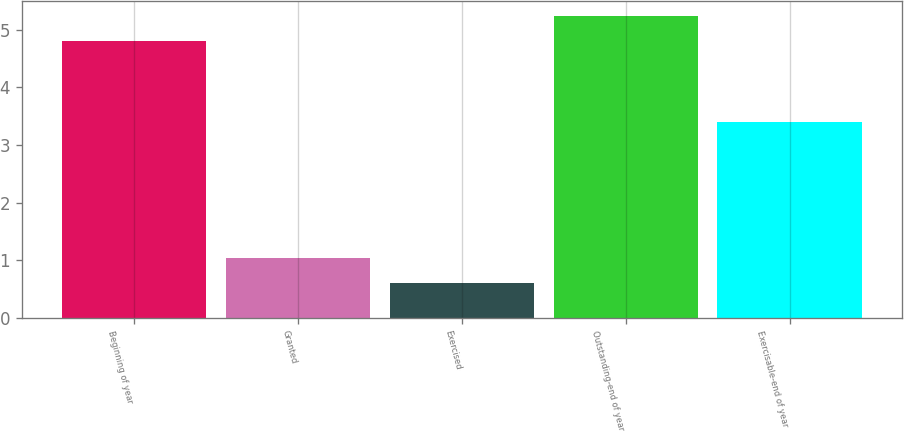Convert chart. <chart><loc_0><loc_0><loc_500><loc_500><bar_chart><fcel>Beginning of year<fcel>Granted<fcel>Exercised<fcel>Outstanding-end of year<fcel>Exercisable-end of year<nl><fcel>4.8<fcel>1.03<fcel>0.6<fcel>5.23<fcel>3.4<nl></chart> 